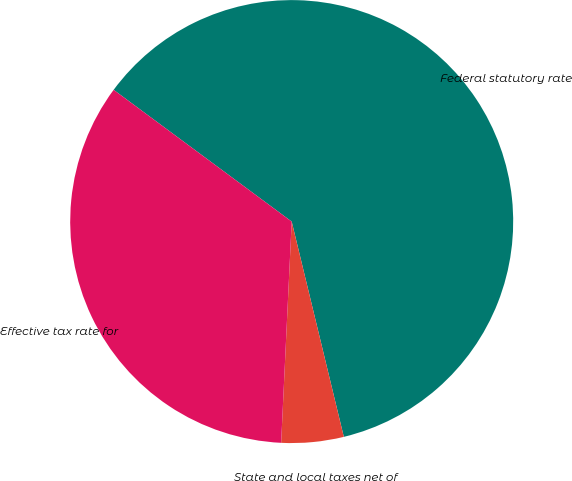Convert chart to OTSL. <chart><loc_0><loc_0><loc_500><loc_500><pie_chart><fcel>Federal statutory rate<fcel>State and local taxes net of<fcel>Effective tax rate for<nl><fcel>61.08%<fcel>4.54%<fcel>34.38%<nl></chart> 